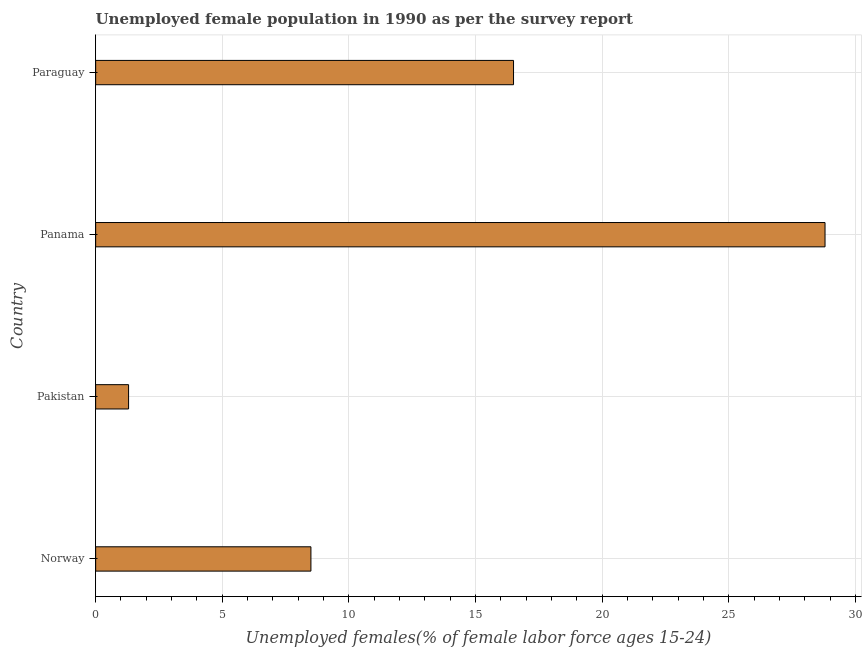Does the graph contain any zero values?
Offer a terse response. No. What is the title of the graph?
Make the answer very short. Unemployed female population in 1990 as per the survey report. What is the label or title of the X-axis?
Provide a succinct answer. Unemployed females(% of female labor force ages 15-24). What is the label or title of the Y-axis?
Provide a succinct answer. Country. What is the unemployed female youth in Pakistan?
Provide a short and direct response. 1.3. Across all countries, what is the maximum unemployed female youth?
Offer a terse response. 28.8. Across all countries, what is the minimum unemployed female youth?
Keep it short and to the point. 1.3. In which country was the unemployed female youth maximum?
Provide a short and direct response. Panama. In which country was the unemployed female youth minimum?
Give a very brief answer. Pakistan. What is the sum of the unemployed female youth?
Your answer should be compact. 55.1. What is the difference between the unemployed female youth in Norway and Panama?
Keep it short and to the point. -20.3. What is the average unemployed female youth per country?
Offer a terse response. 13.78. What is the median unemployed female youth?
Your answer should be compact. 12.5. What is the ratio of the unemployed female youth in Norway to that in Panama?
Your answer should be compact. 0.29. Is the difference between the unemployed female youth in Norway and Panama greater than the difference between any two countries?
Keep it short and to the point. No. What is the difference between the highest and the second highest unemployed female youth?
Offer a very short reply. 12.3. Is the sum of the unemployed female youth in Pakistan and Paraguay greater than the maximum unemployed female youth across all countries?
Ensure brevity in your answer.  No. In how many countries, is the unemployed female youth greater than the average unemployed female youth taken over all countries?
Keep it short and to the point. 2. How many bars are there?
Offer a very short reply. 4. Are all the bars in the graph horizontal?
Make the answer very short. Yes. What is the difference between two consecutive major ticks on the X-axis?
Offer a very short reply. 5. What is the Unemployed females(% of female labor force ages 15-24) in Norway?
Your response must be concise. 8.5. What is the Unemployed females(% of female labor force ages 15-24) of Pakistan?
Make the answer very short. 1.3. What is the Unemployed females(% of female labor force ages 15-24) in Panama?
Your answer should be compact. 28.8. What is the Unemployed females(% of female labor force ages 15-24) in Paraguay?
Your answer should be compact. 16.5. What is the difference between the Unemployed females(% of female labor force ages 15-24) in Norway and Panama?
Your answer should be compact. -20.3. What is the difference between the Unemployed females(% of female labor force ages 15-24) in Pakistan and Panama?
Your response must be concise. -27.5. What is the difference between the Unemployed females(% of female labor force ages 15-24) in Pakistan and Paraguay?
Offer a terse response. -15.2. What is the difference between the Unemployed females(% of female labor force ages 15-24) in Panama and Paraguay?
Offer a terse response. 12.3. What is the ratio of the Unemployed females(% of female labor force ages 15-24) in Norway to that in Pakistan?
Make the answer very short. 6.54. What is the ratio of the Unemployed females(% of female labor force ages 15-24) in Norway to that in Panama?
Your answer should be very brief. 0.29. What is the ratio of the Unemployed females(% of female labor force ages 15-24) in Norway to that in Paraguay?
Give a very brief answer. 0.52. What is the ratio of the Unemployed females(% of female labor force ages 15-24) in Pakistan to that in Panama?
Provide a succinct answer. 0.04. What is the ratio of the Unemployed females(% of female labor force ages 15-24) in Pakistan to that in Paraguay?
Provide a succinct answer. 0.08. What is the ratio of the Unemployed females(% of female labor force ages 15-24) in Panama to that in Paraguay?
Your answer should be compact. 1.75. 